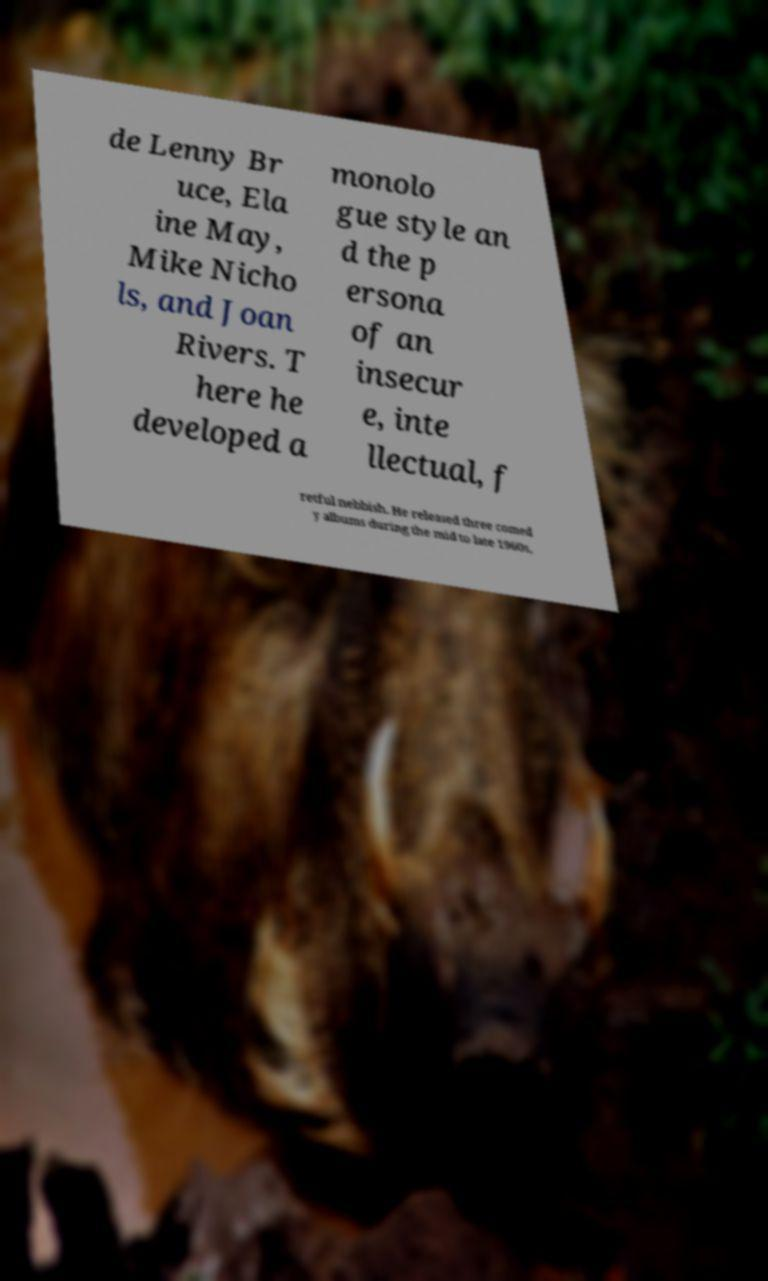Could you extract and type out the text from this image? de Lenny Br uce, Ela ine May, Mike Nicho ls, and Joan Rivers. T here he developed a monolo gue style an d the p ersona of an insecur e, inte llectual, f retful nebbish. He released three comed y albums during the mid to late 1960s, 